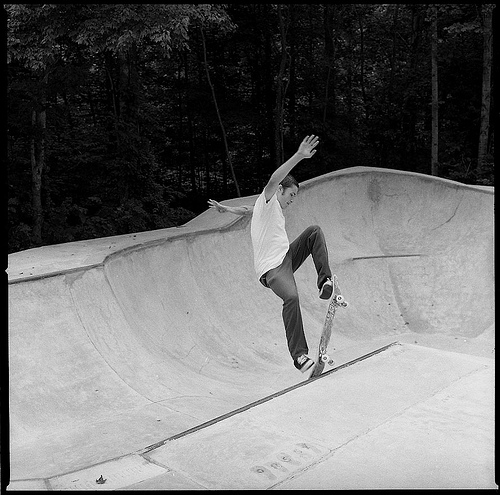<image>Which letters are the man's shadow touching? There is no man's shadow on any letters in the image. Which letters are the man's shadow touching? I don't know which letters are the man's shadow touching. There are no letters in touch with the shadow. 